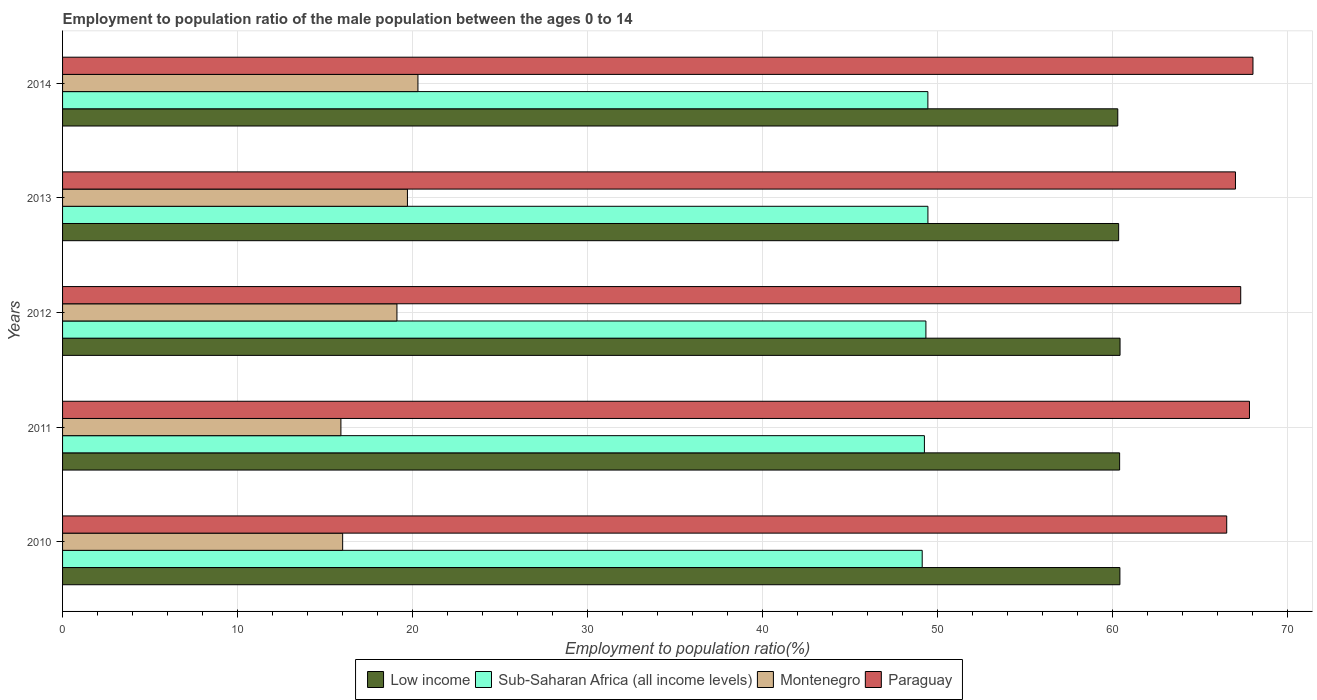Are the number of bars per tick equal to the number of legend labels?
Offer a terse response. Yes. What is the label of the 1st group of bars from the top?
Offer a terse response. 2014. In how many cases, is the number of bars for a given year not equal to the number of legend labels?
Your answer should be very brief. 0. What is the employment to population ratio in Montenegro in 2012?
Make the answer very short. 19.1. Across all years, what is the maximum employment to population ratio in Low income?
Make the answer very short. 60.41. Across all years, what is the minimum employment to population ratio in Montenegro?
Give a very brief answer. 15.9. What is the total employment to population ratio in Low income in the graph?
Give a very brief answer. 301.79. What is the difference between the employment to population ratio in Low income in 2011 and that in 2012?
Ensure brevity in your answer.  -0.02. What is the difference between the employment to population ratio in Low income in 2011 and the employment to population ratio in Paraguay in 2014?
Offer a terse response. -7.62. What is the average employment to population ratio in Montenegro per year?
Your answer should be very brief. 18.2. In the year 2013, what is the difference between the employment to population ratio in Sub-Saharan Africa (all income levels) and employment to population ratio in Paraguay?
Your answer should be very brief. -17.57. In how many years, is the employment to population ratio in Sub-Saharan Africa (all income levels) greater than 26 %?
Provide a succinct answer. 5. What is the ratio of the employment to population ratio in Sub-Saharan Africa (all income levels) in 2010 to that in 2013?
Your answer should be very brief. 0.99. Is the employment to population ratio in Montenegro in 2010 less than that in 2014?
Ensure brevity in your answer.  Yes. Is the difference between the employment to population ratio in Sub-Saharan Africa (all income levels) in 2010 and 2011 greater than the difference between the employment to population ratio in Paraguay in 2010 and 2011?
Your answer should be very brief. Yes. What is the difference between the highest and the second highest employment to population ratio in Montenegro?
Your answer should be compact. 0.6. Is it the case that in every year, the sum of the employment to population ratio in Sub-Saharan Africa (all income levels) and employment to population ratio in Montenegro is greater than the sum of employment to population ratio in Low income and employment to population ratio in Paraguay?
Your answer should be very brief. No. What does the 1st bar from the bottom in 2014 represents?
Your answer should be compact. Low income. Is it the case that in every year, the sum of the employment to population ratio in Sub-Saharan Africa (all income levels) and employment to population ratio in Montenegro is greater than the employment to population ratio in Paraguay?
Keep it short and to the point. No. How many bars are there?
Give a very brief answer. 20. Are all the bars in the graph horizontal?
Your response must be concise. Yes. Where does the legend appear in the graph?
Your answer should be compact. Bottom center. How many legend labels are there?
Your answer should be very brief. 4. What is the title of the graph?
Make the answer very short. Employment to population ratio of the male population between the ages 0 to 14. Does "Panama" appear as one of the legend labels in the graph?
Give a very brief answer. No. What is the Employment to population ratio(%) in Low income in 2010?
Give a very brief answer. 60.4. What is the Employment to population ratio(%) of Sub-Saharan Africa (all income levels) in 2010?
Offer a terse response. 49.11. What is the Employment to population ratio(%) in Paraguay in 2010?
Offer a very short reply. 66.5. What is the Employment to population ratio(%) of Low income in 2011?
Your answer should be very brief. 60.38. What is the Employment to population ratio(%) of Sub-Saharan Africa (all income levels) in 2011?
Give a very brief answer. 49.23. What is the Employment to population ratio(%) of Montenegro in 2011?
Your response must be concise. 15.9. What is the Employment to population ratio(%) in Paraguay in 2011?
Offer a very short reply. 67.8. What is the Employment to population ratio(%) in Low income in 2012?
Provide a succinct answer. 60.41. What is the Employment to population ratio(%) in Sub-Saharan Africa (all income levels) in 2012?
Offer a very short reply. 49.32. What is the Employment to population ratio(%) of Montenegro in 2012?
Make the answer very short. 19.1. What is the Employment to population ratio(%) of Paraguay in 2012?
Provide a short and direct response. 67.3. What is the Employment to population ratio(%) of Low income in 2013?
Your response must be concise. 60.33. What is the Employment to population ratio(%) in Sub-Saharan Africa (all income levels) in 2013?
Ensure brevity in your answer.  49.43. What is the Employment to population ratio(%) in Montenegro in 2013?
Keep it short and to the point. 19.7. What is the Employment to population ratio(%) in Paraguay in 2013?
Your answer should be compact. 67. What is the Employment to population ratio(%) in Low income in 2014?
Make the answer very short. 60.28. What is the Employment to population ratio(%) of Sub-Saharan Africa (all income levels) in 2014?
Your response must be concise. 49.43. What is the Employment to population ratio(%) in Montenegro in 2014?
Keep it short and to the point. 20.3. Across all years, what is the maximum Employment to population ratio(%) in Low income?
Provide a succinct answer. 60.41. Across all years, what is the maximum Employment to population ratio(%) in Sub-Saharan Africa (all income levels)?
Provide a succinct answer. 49.43. Across all years, what is the maximum Employment to population ratio(%) in Montenegro?
Offer a very short reply. 20.3. Across all years, what is the minimum Employment to population ratio(%) in Low income?
Keep it short and to the point. 60.28. Across all years, what is the minimum Employment to population ratio(%) in Sub-Saharan Africa (all income levels)?
Your answer should be compact. 49.11. Across all years, what is the minimum Employment to population ratio(%) of Montenegro?
Make the answer very short. 15.9. Across all years, what is the minimum Employment to population ratio(%) in Paraguay?
Offer a very short reply. 66.5. What is the total Employment to population ratio(%) of Low income in the graph?
Provide a succinct answer. 301.79. What is the total Employment to population ratio(%) in Sub-Saharan Africa (all income levels) in the graph?
Give a very brief answer. 246.51. What is the total Employment to population ratio(%) in Montenegro in the graph?
Make the answer very short. 91. What is the total Employment to population ratio(%) of Paraguay in the graph?
Make the answer very short. 336.6. What is the difference between the Employment to population ratio(%) in Low income in 2010 and that in 2011?
Your answer should be compact. 0.02. What is the difference between the Employment to population ratio(%) of Sub-Saharan Africa (all income levels) in 2010 and that in 2011?
Offer a terse response. -0.13. What is the difference between the Employment to population ratio(%) in Montenegro in 2010 and that in 2011?
Provide a succinct answer. 0.1. What is the difference between the Employment to population ratio(%) in Paraguay in 2010 and that in 2011?
Offer a very short reply. -1.3. What is the difference between the Employment to population ratio(%) of Low income in 2010 and that in 2012?
Keep it short and to the point. -0.01. What is the difference between the Employment to population ratio(%) of Sub-Saharan Africa (all income levels) in 2010 and that in 2012?
Offer a very short reply. -0.21. What is the difference between the Employment to population ratio(%) of Montenegro in 2010 and that in 2012?
Keep it short and to the point. -3.1. What is the difference between the Employment to population ratio(%) in Paraguay in 2010 and that in 2012?
Your answer should be very brief. -0.8. What is the difference between the Employment to population ratio(%) in Low income in 2010 and that in 2013?
Offer a very short reply. 0.07. What is the difference between the Employment to population ratio(%) of Sub-Saharan Africa (all income levels) in 2010 and that in 2013?
Offer a very short reply. -0.33. What is the difference between the Employment to population ratio(%) of Low income in 2010 and that in 2014?
Offer a very short reply. 0.12. What is the difference between the Employment to population ratio(%) in Sub-Saharan Africa (all income levels) in 2010 and that in 2014?
Ensure brevity in your answer.  -0.32. What is the difference between the Employment to population ratio(%) in Montenegro in 2010 and that in 2014?
Ensure brevity in your answer.  -4.3. What is the difference between the Employment to population ratio(%) of Low income in 2011 and that in 2012?
Give a very brief answer. -0.02. What is the difference between the Employment to population ratio(%) of Sub-Saharan Africa (all income levels) in 2011 and that in 2012?
Your answer should be compact. -0.08. What is the difference between the Employment to population ratio(%) in Low income in 2011 and that in 2013?
Make the answer very short. 0.06. What is the difference between the Employment to population ratio(%) of Sub-Saharan Africa (all income levels) in 2011 and that in 2013?
Provide a succinct answer. -0.2. What is the difference between the Employment to population ratio(%) in Paraguay in 2011 and that in 2013?
Ensure brevity in your answer.  0.8. What is the difference between the Employment to population ratio(%) in Low income in 2011 and that in 2014?
Your answer should be very brief. 0.11. What is the difference between the Employment to population ratio(%) in Sub-Saharan Africa (all income levels) in 2011 and that in 2014?
Provide a short and direct response. -0.2. What is the difference between the Employment to population ratio(%) of Montenegro in 2011 and that in 2014?
Offer a very short reply. -4.4. What is the difference between the Employment to population ratio(%) of Low income in 2012 and that in 2013?
Offer a terse response. 0.08. What is the difference between the Employment to population ratio(%) in Sub-Saharan Africa (all income levels) in 2012 and that in 2013?
Make the answer very short. -0.12. What is the difference between the Employment to population ratio(%) of Low income in 2012 and that in 2014?
Offer a terse response. 0.13. What is the difference between the Employment to population ratio(%) in Sub-Saharan Africa (all income levels) in 2012 and that in 2014?
Your answer should be very brief. -0.11. What is the difference between the Employment to population ratio(%) of Paraguay in 2012 and that in 2014?
Make the answer very short. -0.7. What is the difference between the Employment to population ratio(%) of Low income in 2013 and that in 2014?
Provide a succinct answer. 0.05. What is the difference between the Employment to population ratio(%) of Sub-Saharan Africa (all income levels) in 2013 and that in 2014?
Give a very brief answer. 0. What is the difference between the Employment to population ratio(%) of Montenegro in 2013 and that in 2014?
Provide a short and direct response. -0.6. What is the difference between the Employment to population ratio(%) in Low income in 2010 and the Employment to population ratio(%) in Sub-Saharan Africa (all income levels) in 2011?
Offer a terse response. 11.17. What is the difference between the Employment to population ratio(%) in Low income in 2010 and the Employment to population ratio(%) in Montenegro in 2011?
Your response must be concise. 44.5. What is the difference between the Employment to population ratio(%) in Low income in 2010 and the Employment to population ratio(%) in Paraguay in 2011?
Your response must be concise. -7.4. What is the difference between the Employment to population ratio(%) of Sub-Saharan Africa (all income levels) in 2010 and the Employment to population ratio(%) of Montenegro in 2011?
Give a very brief answer. 33.21. What is the difference between the Employment to population ratio(%) in Sub-Saharan Africa (all income levels) in 2010 and the Employment to population ratio(%) in Paraguay in 2011?
Your answer should be compact. -18.69. What is the difference between the Employment to population ratio(%) in Montenegro in 2010 and the Employment to population ratio(%) in Paraguay in 2011?
Your answer should be very brief. -51.8. What is the difference between the Employment to population ratio(%) in Low income in 2010 and the Employment to population ratio(%) in Sub-Saharan Africa (all income levels) in 2012?
Your answer should be compact. 11.08. What is the difference between the Employment to population ratio(%) of Low income in 2010 and the Employment to population ratio(%) of Montenegro in 2012?
Offer a terse response. 41.3. What is the difference between the Employment to population ratio(%) of Low income in 2010 and the Employment to population ratio(%) of Paraguay in 2012?
Ensure brevity in your answer.  -6.9. What is the difference between the Employment to population ratio(%) in Sub-Saharan Africa (all income levels) in 2010 and the Employment to population ratio(%) in Montenegro in 2012?
Keep it short and to the point. 30.01. What is the difference between the Employment to population ratio(%) in Sub-Saharan Africa (all income levels) in 2010 and the Employment to population ratio(%) in Paraguay in 2012?
Make the answer very short. -18.19. What is the difference between the Employment to population ratio(%) in Montenegro in 2010 and the Employment to population ratio(%) in Paraguay in 2012?
Your response must be concise. -51.3. What is the difference between the Employment to population ratio(%) in Low income in 2010 and the Employment to population ratio(%) in Sub-Saharan Africa (all income levels) in 2013?
Offer a very short reply. 10.97. What is the difference between the Employment to population ratio(%) of Low income in 2010 and the Employment to population ratio(%) of Montenegro in 2013?
Provide a short and direct response. 40.7. What is the difference between the Employment to population ratio(%) in Low income in 2010 and the Employment to population ratio(%) in Paraguay in 2013?
Keep it short and to the point. -6.6. What is the difference between the Employment to population ratio(%) of Sub-Saharan Africa (all income levels) in 2010 and the Employment to population ratio(%) of Montenegro in 2013?
Make the answer very short. 29.41. What is the difference between the Employment to population ratio(%) of Sub-Saharan Africa (all income levels) in 2010 and the Employment to population ratio(%) of Paraguay in 2013?
Offer a very short reply. -17.89. What is the difference between the Employment to population ratio(%) in Montenegro in 2010 and the Employment to population ratio(%) in Paraguay in 2013?
Make the answer very short. -51. What is the difference between the Employment to population ratio(%) in Low income in 2010 and the Employment to population ratio(%) in Sub-Saharan Africa (all income levels) in 2014?
Keep it short and to the point. 10.97. What is the difference between the Employment to population ratio(%) in Low income in 2010 and the Employment to population ratio(%) in Montenegro in 2014?
Your answer should be compact. 40.1. What is the difference between the Employment to population ratio(%) of Low income in 2010 and the Employment to population ratio(%) of Paraguay in 2014?
Ensure brevity in your answer.  -7.6. What is the difference between the Employment to population ratio(%) in Sub-Saharan Africa (all income levels) in 2010 and the Employment to population ratio(%) in Montenegro in 2014?
Make the answer very short. 28.81. What is the difference between the Employment to population ratio(%) of Sub-Saharan Africa (all income levels) in 2010 and the Employment to population ratio(%) of Paraguay in 2014?
Your answer should be very brief. -18.89. What is the difference between the Employment to population ratio(%) of Montenegro in 2010 and the Employment to population ratio(%) of Paraguay in 2014?
Make the answer very short. -52. What is the difference between the Employment to population ratio(%) of Low income in 2011 and the Employment to population ratio(%) of Sub-Saharan Africa (all income levels) in 2012?
Provide a short and direct response. 11.07. What is the difference between the Employment to population ratio(%) of Low income in 2011 and the Employment to population ratio(%) of Montenegro in 2012?
Provide a short and direct response. 41.28. What is the difference between the Employment to population ratio(%) in Low income in 2011 and the Employment to population ratio(%) in Paraguay in 2012?
Provide a succinct answer. -6.92. What is the difference between the Employment to population ratio(%) of Sub-Saharan Africa (all income levels) in 2011 and the Employment to population ratio(%) of Montenegro in 2012?
Offer a terse response. 30.13. What is the difference between the Employment to population ratio(%) in Sub-Saharan Africa (all income levels) in 2011 and the Employment to population ratio(%) in Paraguay in 2012?
Make the answer very short. -18.07. What is the difference between the Employment to population ratio(%) in Montenegro in 2011 and the Employment to population ratio(%) in Paraguay in 2012?
Offer a terse response. -51.4. What is the difference between the Employment to population ratio(%) of Low income in 2011 and the Employment to population ratio(%) of Sub-Saharan Africa (all income levels) in 2013?
Give a very brief answer. 10.95. What is the difference between the Employment to population ratio(%) in Low income in 2011 and the Employment to population ratio(%) in Montenegro in 2013?
Ensure brevity in your answer.  40.68. What is the difference between the Employment to population ratio(%) in Low income in 2011 and the Employment to population ratio(%) in Paraguay in 2013?
Give a very brief answer. -6.62. What is the difference between the Employment to population ratio(%) of Sub-Saharan Africa (all income levels) in 2011 and the Employment to population ratio(%) of Montenegro in 2013?
Offer a very short reply. 29.53. What is the difference between the Employment to population ratio(%) of Sub-Saharan Africa (all income levels) in 2011 and the Employment to population ratio(%) of Paraguay in 2013?
Your response must be concise. -17.77. What is the difference between the Employment to population ratio(%) of Montenegro in 2011 and the Employment to population ratio(%) of Paraguay in 2013?
Offer a very short reply. -51.1. What is the difference between the Employment to population ratio(%) of Low income in 2011 and the Employment to population ratio(%) of Sub-Saharan Africa (all income levels) in 2014?
Keep it short and to the point. 10.95. What is the difference between the Employment to population ratio(%) of Low income in 2011 and the Employment to population ratio(%) of Montenegro in 2014?
Provide a short and direct response. 40.08. What is the difference between the Employment to population ratio(%) of Low income in 2011 and the Employment to population ratio(%) of Paraguay in 2014?
Your answer should be very brief. -7.62. What is the difference between the Employment to population ratio(%) of Sub-Saharan Africa (all income levels) in 2011 and the Employment to population ratio(%) of Montenegro in 2014?
Offer a very short reply. 28.93. What is the difference between the Employment to population ratio(%) in Sub-Saharan Africa (all income levels) in 2011 and the Employment to population ratio(%) in Paraguay in 2014?
Ensure brevity in your answer.  -18.77. What is the difference between the Employment to population ratio(%) of Montenegro in 2011 and the Employment to population ratio(%) of Paraguay in 2014?
Provide a short and direct response. -52.1. What is the difference between the Employment to population ratio(%) of Low income in 2012 and the Employment to population ratio(%) of Sub-Saharan Africa (all income levels) in 2013?
Provide a short and direct response. 10.98. What is the difference between the Employment to population ratio(%) of Low income in 2012 and the Employment to population ratio(%) of Montenegro in 2013?
Ensure brevity in your answer.  40.71. What is the difference between the Employment to population ratio(%) in Low income in 2012 and the Employment to population ratio(%) in Paraguay in 2013?
Offer a very short reply. -6.59. What is the difference between the Employment to population ratio(%) in Sub-Saharan Africa (all income levels) in 2012 and the Employment to population ratio(%) in Montenegro in 2013?
Offer a terse response. 29.62. What is the difference between the Employment to population ratio(%) of Sub-Saharan Africa (all income levels) in 2012 and the Employment to population ratio(%) of Paraguay in 2013?
Provide a succinct answer. -17.68. What is the difference between the Employment to population ratio(%) in Montenegro in 2012 and the Employment to population ratio(%) in Paraguay in 2013?
Give a very brief answer. -47.9. What is the difference between the Employment to population ratio(%) in Low income in 2012 and the Employment to population ratio(%) in Sub-Saharan Africa (all income levels) in 2014?
Your answer should be compact. 10.98. What is the difference between the Employment to population ratio(%) in Low income in 2012 and the Employment to population ratio(%) in Montenegro in 2014?
Your response must be concise. 40.11. What is the difference between the Employment to population ratio(%) of Low income in 2012 and the Employment to population ratio(%) of Paraguay in 2014?
Your answer should be very brief. -7.59. What is the difference between the Employment to population ratio(%) of Sub-Saharan Africa (all income levels) in 2012 and the Employment to population ratio(%) of Montenegro in 2014?
Your response must be concise. 29.02. What is the difference between the Employment to population ratio(%) of Sub-Saharan Africa (all income levels) in 2012 and the Employment to population ratio(%) of Paraguay in 2014?
Give a very brief answer. -18.68. What is the difference between the Employment to population ratio(%) in Montenegro in 2012 and the Employment to population ratio(%) in Paraguay in 2014?
Keep it short and to the point. -48.9. What is the difference between the Employment to population ratio(%) of Low income in 2013 and the Employment to population ratio(%) of Sub-Saharan Africa (all income levels) in 2014?
Your response must be concise. 10.9. What is the difference between the Employment to population ratio(%) of Low income in 2013 and the Employment to population ratio(%) of Montenegro in 2014?
Your answer should be very brief. 40.03. What is the difference between the Employment to population ratio(%) of Low income in 2013 and the Employment to population ratio(%) of Paraguay in 2014?
Your response must be concise. -7.67. What is the difference between the Employment to population ratio(%) of Sub-Saharan Africa (all income levels) in 2013 and the Employment to population ratio(%) of Montenegro in 2014?
Offer a very short reply. 29.13. What is the difference between the Employment to population ratio(%) in Sub-Saharan Africa (all income levels) in 2013 and the Employment to population ratio(%) in Paraguay in 2014?
Offer a terse response. -18.57. What is the difference between the Employment to population ratio(%) in Montenegro in 2013 and the Employment to population ratio(%) in Paraguay in 2014?
Offer a terse response. -48.3. What is the average Employment to population ratio(%) in Low income per year?
Provide a short and direct response. 60.36. What is the average Employment to population ratio(%) of Sub-Saharan Africa (all income levels) per year?
Give a very brief answer. 49.3. What is the average Employment to population ratio(%) in Paraguay per year?
Make the answer very short. 67.32. In the year 2010, what is the difference between the Employment to population ratio(%) in Low income and Employment to population ratio(%) in Sub-Saharan Africa (all income levels)?
Your answer should be very brief. 11.29. In the year 2010, what is the difference between the Employment to population ratio(%) in Low income and Employment to population ratio(%) in Montenegro?
Provide a short and direct response. 44.4. In the year 2010, what is the difference between the Employment to population ratio(%) in Low income and Employment to population ratio(%) in Paraguay?
Provide a succinct answer. -6.1. In the year 2010, what is the difference between the Employment to population ratio(%) in Sub-Saharan Africa (all income levels) and Employment to population ratio(%) in Montenegro?
Ensure brevity in your answer.  33.11. In the year 2010, what is the difference between the Employment to population ratio(%) in Sub-Saharan Africa (all income levels) and Employment to population ratio(%) in Paraguay?
Keep it short and to the point. -17.39. In the year 2010, what is the difference between the Employment to population ratio(%) of Montenegro and Employment to population ratio(%) of Paraguay?
Your response must be concise. -50.5. In the year 2011, what is the difference between the Employment to population ratio(%) of Low income and Employment to population ratio(%) of Sub-Saharan Africa (all income levels)?
Give a very brief answer. 11.15. In the year 2011, what is the difference between the Employment to population ratio(%) of Low income and Employment to population ratio(%) of Montenegro?
Offer a terse response. 44.48. In the year 2011, what is the difference between the Employment to population ratio(%) of Low income and Employment to population ratio(%) of Paraguay?
Give a very brief answer. -7.42. In the year 2011, what is the difference between the Employment to population ratio(%) of Sub-Saharan Africa (all income levels) and Employment to population ratio(%) of Montenegro?
Keep it short and to the point. 33.33. In the year 2011, what is the difference between the Employment to population ratio(%) in Sub-Saharan Africa (all income levels) and Employment to population ratio(%) in Paraguay?
Your response must be concise. -18.57. In the year 2011, what is the difference between the Employment to population ratio(%) of Montenegro and Employment to population ratio(%) of Paraguay?
Your answer should be compact. -51.9. In the year 2012, what is the difference between the Employment to population ratio(%) of Low income and Employment to population ratio(%) of Sub-Saharan Africa (all income levels)?
Give a very brief answer. 11.09. In the year 2012, what is the difference between the Employment to population ratio(%) of Low income and Employment to population ratio(%) of Montenegro?
Your answer should be very brief. 41.31. In the year 2012, what is the difference between the Employment to population ratio(%) in Low income and Employment to population ratio(%) in Paraguay?
Provide a short and direct response. -6.89. In the year 2012, what is the difference between the Employment to population ratio(%) in Sub-Saharan Africa (all income levels) and Employment to population ratio(%) in Montenegro?
Keep it short and to the point. 30.22. In the year 2012, what is the difference between the Employment to population ratio(%) of Sub-Saharan Africa (all income levels) and Employment to population ratio(%) of Paraguay?
Provide a short and direct response. -17.98. In the year 2012, what is the difference between the Employment to population ratio(%) of Montenegro and Employment to population ratio(%) of Paraguay?
Provide a succinct answer. -48.2. In the year 2013, what is the difference between the Employment to population ratio(%) of Low income and Employment to population ratio(%) of Sub-Saharan Africa (all income levels)?
Your response must be concise. 10.9. In the year 2013, what is the difference between the Employment to population ratio(%) in Low income and Employment to population ratio(%) in Montenegro?
Provide a short and direct response. 40.63. In the year 2013, what is the difference between the Employment to population ratio(%) of Low income and Employment to population ratio(%) of Paraguay?
Give a very brief answer. -6.67. In the year 2013, what is the difference between the Employment to population ratio(%) of Sub-Saharan Africa (all income levels) and Employment to population ratio(%) of Montenegro?
Ensure brevity in your answer.  29.73. In the year 2013, what is the difference between the Employment to population ratio(%) of Sub-Saharan Africa (all income levels) and Employment to population ratio(%) of Paraguay?
Offer a very short reply. -17.57. In the year 2013, what is the difference between the Employment to population ratio(%) of Montenegro and Employment to population ratio(%) of Paraguay?
Give a very brief answer. -47.3. In the year 2014, what is the difference between the Employment to population ratio(%) in Low income and Employment to population ratio(%) in Sub-Saharan Africa (all income levels)?
Give a very brief answer. 10.85. In the year 2014, what is the difference between the Employment to population ratio(%) of Low income and Employment to population ratio(%) of Montenegro?
Your answer should be very brief. 39.98. In the year 2014, what is the difference between the Employment to population ratio(%) in Low income and Employment to population ratio(%) in Paraguay?
Provide a short and direct response. -7.72. In the year 2014, what is the difference between the Employment to population ratio(%) in Sub-Saharan Africa (all income levels) and Employment to population ratio(%) in Montenegro?
Your answer should be very brief. 29.13. In the year 2014, what is the difference between the Employment to population ratio(%) in Sub-Saharan Africa (all income levels) and Employment to population ratio(%) in Paraguay?
Provide a succinct answer. -18.57. In the year 2014, what is the difference between the Employment to population ratio(%) in Montenegro and Employment to population ratio(%) in Paraguay?
Ensure brevity in your answer.  -47.7. What is the ratio of the Employment to population ratio(%) in Montenegro in 2010 to that in 2011?
Give a very brief answer. 1.01. What is the ratio of the Employment to population ratio(%) in Paraguay in 2010 to that in 2011?
Your answer should be compact. 0.98. What is the ratio of the Employment to population ratio(%) in Low income in 2010 to that in 2012?
Your answer should be very brief. 1. What is the ratio of the Employment to population ratio(%) of Montenegro in 2010 to that in 2012?
Ensure brevity in your answer.  0.84. What is the ratio of the Employment to population ratio(%) of Sub-Saharan Africa (all income levels) in 2010 to that in 2013?
Give a very brief answer. 0.99. What is the ratio of the Employment to population ratio(%) in Montenegro in 2010 to that in 2013?
Provide a succinct answer. 0.81. What is the ratio of the Employment to population ratio(%) of Montenegro in 2010 to that in 2014?
Offer a terse response. 0.79. What is the ratio of the Employment to population ratio(%) in Paraguay in 2010 to that in 2014?
Give a very brief answer. 0.98. What is the ratio of the Employment to population ratio(%) in Montenegro in 2011 to that in 2012?
Your answer should be very brief. 0.83. What is the ratio of the Employment to population ratio(%) in Paraguay in 2011 to that in 2012?
Keep it short and to the point. 1.01. What is the ratio of the Employment to population ratio(%) of Low income in 2011 to that in 2013?
Provide a short and direct response. 1. What is the ratio of the Employment to population ratio(%) in Montenegro in 2011 to that in 2013?
Ensure brevity in your answer.  0.81. What is the ratio of the Employment to population ratio(%) of Paraguay in 2011 to that in 2013?
Provide a short and direct response. 1.01. What is the ratio of the Employment to population ratio(%) of Low income in 2011 to that in 2014?
Your response must be concise. 1. What is the ratio of the Employment to population ratio(%) in Montenegro in 2011 to that in 2014?
Ensure brevity in your answer.  0.78. What is the ratio of the Employment to population ratio(%) of Paraguay in 2011 to that in 2014?
Keep it short and to the point. 1. What is the ratio of the Employment to population ratio(%) in Montenegro in 2012 to that in 2013?
Your answer should be compact. 0.97. What is the ratio of the Employment to population ratio(%) in Paraguay in 2012 to that in 2013?
Make the answer very short. 1. What is the ratio of the Employment to population ratio(%) in Montenegro in 2012 to that in 2014?
Offer a very short reply. 0.94. What is the ratio of the Employment to population ratio(%) of Low income in 2013 to that in 2014?
Give a very brief answer. 1. What is the ratio of the Employment to population ratio(%) of Sub-Saharan Africa (all income levels) in 2013 to that in 2014?
Your response must be concise. 1. What is the ratio of the Employment to population ratio(%) of Montenegro in 2013 to that in 2014?
Ensure brevity in your answer.  0.97. What is the ratio of the Employment to population ratio(%) in Paraguay in 2013 to that in 2014?
Give a very brief answer. 0.99. What is the difference between the highest and the second highest Employment to population ratio(%) of Low income?
Make the answer very short. 0.01. What is the difference between the highest and the second highest Employment to population ratio(%) of Sub-Saharan Africa (all income levels)?
Offer a very short reply. 0. What is the difference between the highest and the lowest Employment to population ratio(%) of Low income?
Provide a succinct answer. 0.13. What is the difference between the highest and the lowest Employment to population ratio(%) in Sub-Saharan Africa (all income levels)?
Keep it short and to the point. 0.33. What is the difference between the highest and the lowest Employment to population ratio(%) of Paraguay?
Provide a succinct answer. 1.5. 